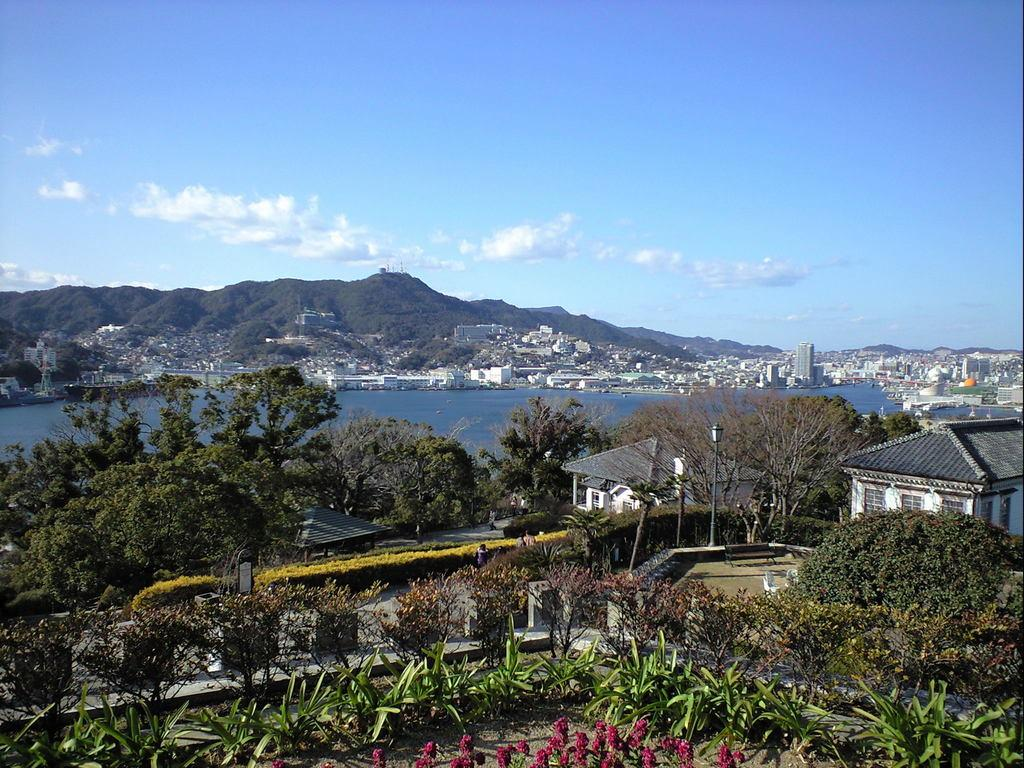What is located in the center of the image? There are trees in the center of the image. What type of structures can be seen in the image? There are sheds in the image. What type of vegetation is at the bottom of the image? There are plants at the bottom of the image. What can be seen in the background of the image? Water, buildings, hills, and the sky are visible in the background of the image. Are there any people in the image? Yes, people are present in the image. How many cherries are hanging from the trees in the image? There is no mention of cherries in the image; it features trees, sheds, plants, water, buildings, hills, the sky, and people. What is the value of the wilderness depicted in the image? The image does not depict a wilderness; it features a combination of natural and man-made elements, including trees, sheds, plants, water, buildings, hills, the sky, and people. 